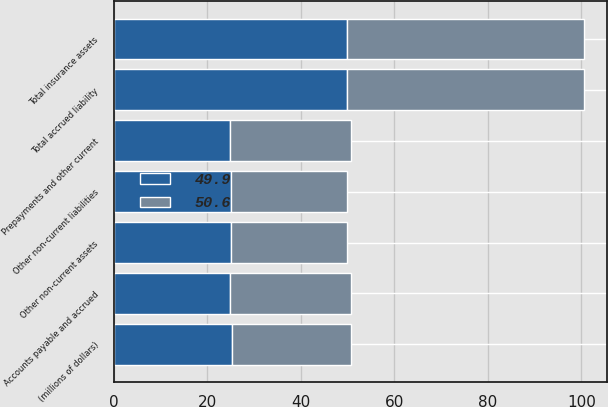Convert chart to OTSL. <chart><loc_0><loc_0><loc_500><loc_500><stacked_bar_chart><ecel><fcel>(millions of dollars)<fcel>Prepayments and other current<fcel>Other non-current assets<fcel>Total insurance assets<fcel>Accounts payable and accrued<fcel>Other non-current liabilities<fcel>Total accrued liability<nl><fcel>50.6<fcel>25.4<fcel>25.8<fcel>24.8<fcel>50.6<fcel>25.8<fcel>24.8<fcel>50.6<nl><fcel>49.9<fcel>25.4<fcel>24.9<fcel>25<fcel>49.9<fcel>24.9<fcel>25<fcel>49.9<nl></chart> 